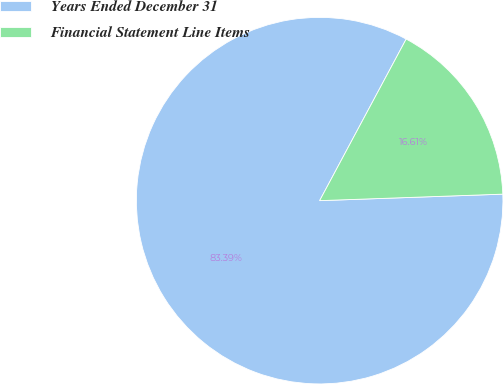Convert chart. <chart><loc_0><loc_0><loc_500><loc_500><pie_chart><fcel>Years Ended December 31<fcel>Financial Statement Line Items<nl><fcel>83.39%<fcel>16.61%<nl></chart> 